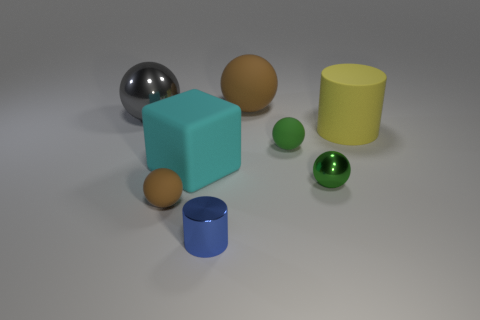Subtract all gray spheres. How many spheres are left? 4 Subtract all big brown balls. How many balls are left? 4 Subtract 1 spheres. How many spheres are left? 4 Subtract all purple balls. Subtract all yellow blocks. How many balls are left? 5 Add 2 small rubber objects. How many objects exist? 10 Subtract all balls. How many objects are left? 3 Add 2 cyan rubber blocks. How many cyan rubber blocks exist? 3 Subtract 0 purple cubes. How many objects are left? 8 Subtract all tiny green metal cylinders. Subtract all big cyan objects. How many objects are left? 7 Add 4 shiny spheres. How many shiny spheres are left? 6 